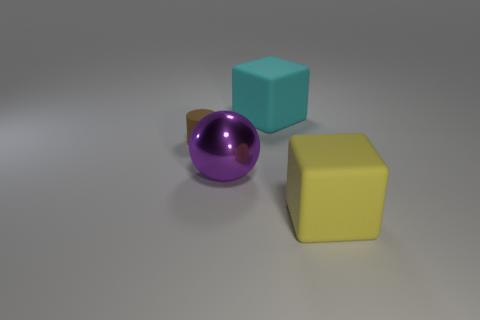Add 1 big spheres. How many objects exist? 5 Subtract all cylinders. How many objects are left? 3 Subtract all rubber things. Subtract all large cyan objects. How many objects are left? 0 Add 2 large yellow cubes. How many large yellow cubes are left? 3 Add 3 brown metallic balls. How many brown metallic balls exist? 3 Subtract 0 blue balls. How many objects are left? 4 